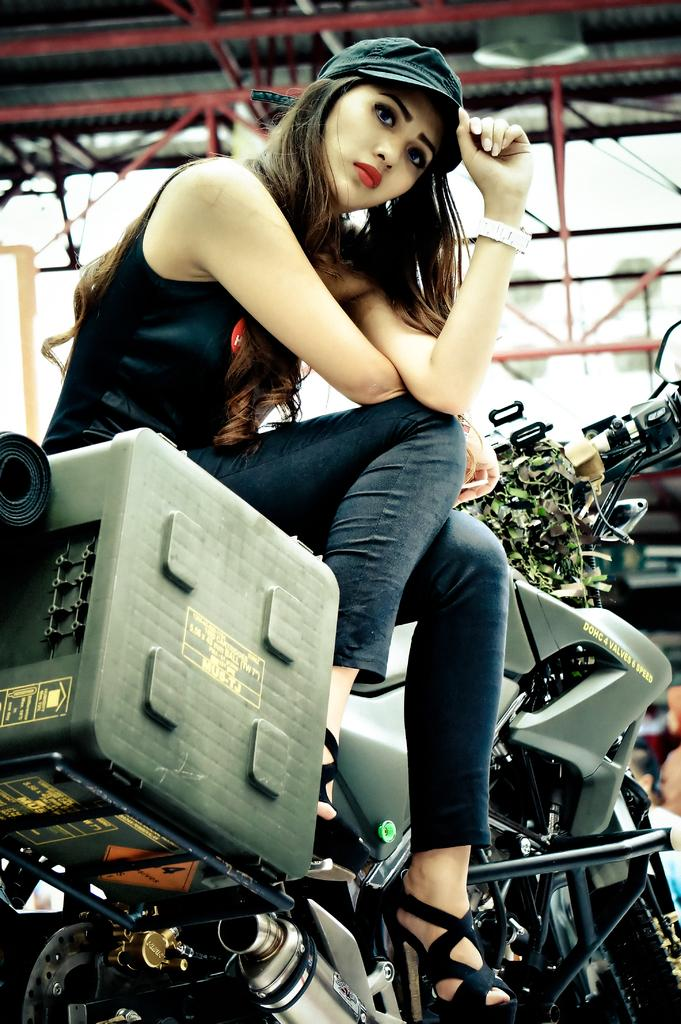Who is the main subject in the image? There is a woman in the image. What is the woman doing in the image? The woman is seated on a motorcycle. What is the woman wearing on her head? The woman is wearing a cap on her head. What type of apples can be seen on the woman's tongue in the image? There are no apples or any reference to a tongue in the image; the woman is wearing a cap on her head and sitting on a motorcycle. 